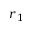Convert formula to latex. <formula><loc_0><loc_0><loc_500><loc_500>r _ { 1 }</formula> 